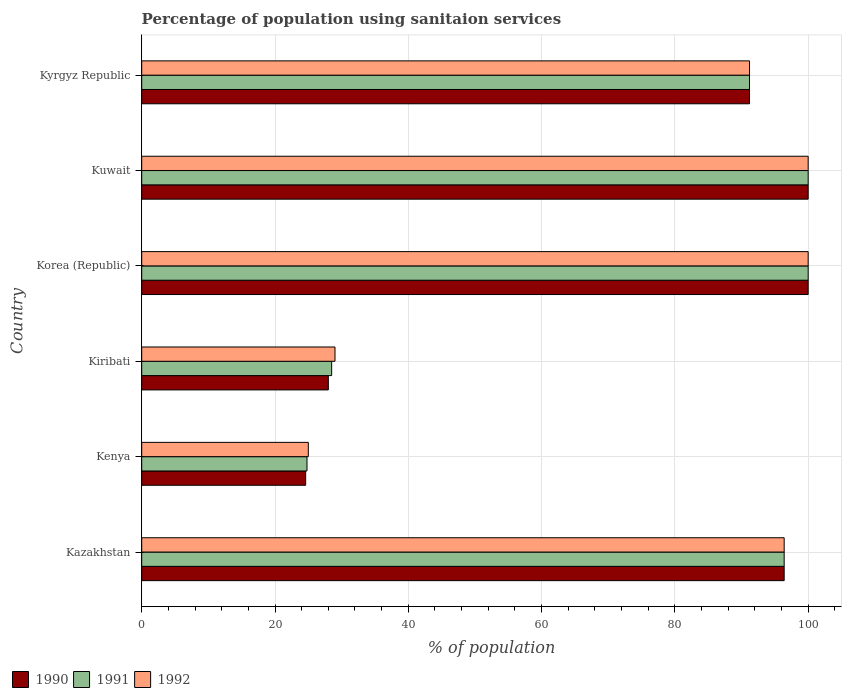How many different coloured bars are there?
Offer a very short reply. 3. How many bars are there on the 2nd tick from the top?
Your answer should be compact. 3. How many bars are there on the 6th tick from the bottom?
Keep it short and to the point. 3. What is the label of the 3rd group of bars from the top?
Offer a terse response. Korea (Republic). What is the percentage of population using sanitaion services in 1990 in Kyrgyz Republic?
Your answer should be very brief. 91.2. Across all countries, what is the maximum percentage of population using sanitaion services in 1990?
Your answer should be very brief. 100. Across all countries, what is the minimum percentage of population using sanitaion services in 1991?
Your answer should be compact. 24.8. In which country was the percentage of population using sanitaion services in 1992 maximum?
Your answer should be compact. Korea (Republic). In which country was the percentage of population using sanitaion services in 1992 minimum?
Your response must be concise. Kenya. What is the total percentage of population using sanitaion services in 1991 in the graph?
Make the answer very short. 440.9. What is the difference between the percentage of population using sanitaion services in 1990 in Kazakhstan and that in Kyrgyz Republic?
Your response must be concise. 5.2. What is the difference between the percentage of population using sanitaion services in 1992 in Kenya and the percentage of population using sanitaion services in 1990 in Kyrgyz Republic?
Make the answer very short. -66.2. What is the average percentage of population using sanitaion services in 1990 per country?
Provide a short and direct response. 73.37. What is the difference between the percentage of population using sanitaion services in 1992 and percentage of population using sanitaion services in 1990 in Kazakhstan?
Ensure brevity in your answer.  0. What is the ratio of the percentage of population using sanitaion services in 1990 in Kiribati to that in Kuwait?
Provide a succinct answer. 0.28. Is the percentage of population using sanitaion services in 1990 in Kuwait less than that in Kyrgyz Republic?
Make the answer very short. No. Is the difference between the percentage of population using sanitaion services in 1992 in Kiribati and Korea (Republic) greater than the difference between the percentage of population using sanitaion services in 1990 in Kiribati and Korea (Republic)?
Ensure brevity in your answer.  Yes. What is the difference between the highest and the second highest percentage of population using sanitaion services in 1991?
Your answer should be compact. 0. What is the difference between the highest and the lowest percentage of population using sanitaion services in 1992?
Offer a very short reply. 75. In how many countries, is the percentage of population using sanitaion services in 1990 greater than the average percentage of population using sanitaion services in 1990 taken over all countries?
Make the answer very short. 4. Is the sum of the percentage of population using sanitaion services in 1990 in Kiribati and Kyrgyz Republic greater than the maximum percentage of population using sanitaion services in 1992 across all countries?
Provide a succinct answer. Yes. What does the 3rd bar from the top in Kazakhstan represents?
Provide a short and direct response. 1990. What does the 1st bar from the bottom in Kiribati represents?
Your answer should be very brief. 1990. Is it the case that in every country, the sum of the percentage of population using sanitaion services in 1990 and percentage of population using sanitaion services in 1991 is greater than the percentage of population using sanitaion services in 1992?
Provide a short and direct response. Yes. How many bars are there?
Keep it short and to the point. 18. Are all the bars in the graph horizontal?
Ensure brevity in your answer.  Yes. How many countries are there in the graph?
Ensure brevity in your answer.  6. What is the difference between two consecutive major ticks on the X-axis?
Your answer should be very brief. 20. Are the values on the major ticks of X-axis written in scientific E-notation?
Ensure brevity in your answer.  No. How are the legend labels stacked?
Ensure brevity in your answer.  Horizontal. What is the title of the graph?
Offer a very short reply. Percentage of population using sanitaion services. Does "2003" appear as one of the legend labels in the graph?
Provide a succinct answer. No. What is the label or title of the X-axis?
Keep it short and to the point. % of population. What is the label or title of the Y-axis?
Offer a very short reply. Country. What is the % of population in 1990 in Kazakhstan?
Offer a terse response. 96.4. What is the % of population of 1991 in Kazakhstan?
Your answer should be very brief. 96.4. What is the % of population of 1992 in Kazakhstan?
Give a very brief answer. 96.4. What is the % of population of 1990 in Kenya?
Make the answer very short. 24.6. What is the % of population in 1991 in Kenya?
Give a very brief answer. 24.8. What is the % of population in 1991 in Korea (Republic)?
Make the answer very short. 100. What is the % of population in 1992 in Korea (Republic)?
Offer a very short reply. 100. What is the % of population of 1990 in Kyrgyz Republic?
Your response must be concise. 91.2. What is the % of population of 1991 in Kyrgyz Republic?
Ensure brevity in your answer.  91.2. What is the % of population in 1992 in Kyrgyz Republic?
Your answer should be compact. 91.2. Across all countries, what is the maximum % of population of 1990?
Offer a very short reply. 100. Across all countries, what is the maximum % of population of 1991?
Your answer should be compact. 100. Across all countries, what is the maximum % of population in 1992?
Your response must be concise. 100. Across all countries, what is the minimum % of population of 1990?
Your answer should be compact. 24.6. Across all countries, what is the minimum % of population in 1991?
Offer a very short reply. 24.8. What is the total % of population of 1990 in the graph?
Make the answer very short. 440.2. What is the total % of population of 1991 in the graph?
Provide a short and direct response. 440.9. What is the total % of population in 1992 in the graph?
Ensure brevity in your answer.  441.6. What is the difference between the % of population in 1990 in Kazakhstan and that in Kenya?
Your answer should be compact. 71.8. What is the difference between the % of population of 1991 in Kazakhstan and that in Kenya?
Give a very brief answer. 71.6. What is the difference between the % of population of 1992 in Kazakhstan and that in Kenya?
Your answer should be very brief. 71.4. What is the difference between the % of population in 1990 in Kazakhstan and that in Kiribati?
Give a very brief answer. 68.4. What is the difference between the % of population in 1991 in Kazakhstan and that in Kiribati?
Your answer should be compact. 67.9. What is the difference between the % of population of 1992 in Kazakhstan and that in Kiribati?
Provide a succinct answer. 67.4. What is the difference between the % of population in 1991 in Kazakhstan and that in Korea (Republic)?
Provide a short and direct response. -3.6. What is the difference between the % of population in 1990 in Kazakhstan and that in Kuwait?
Your response must be concise. -3.6. What is the difference between the % of population in 1992 in Kazakhstan and that in Kuwait?
Provide a succinct answer. -3.6. What is the difference between the % of population of 1990 in Kazakhstan and that in Kyrgyz Republic?
Provide a succinct answer. 5.2. What is the difference between the % of population in 1991 in Kazakhstan and that in Kyrgyz Republic?
Your response must be concise. 5.2. What is the difference between the % of population of 1992 in Kazakhstan and that in Kyrgyz Republic?
Your response must be concise. 5.2. What is the difference between the % of population of 1990 in Kenya and that in Kiribati?
Provide a succinct answer. -3.4. What is the difference between the % of population of 1992 in Kenya and that in Kiribati?
Your response must be concise. -4. What is the difference between the % of population in 1990 in Kenya and that in Korea (Republic)?
Offer a very short reply. -75.4. What is the difference between the % of population of 1991 in Kenya and that in Korea (Republic)?
Provide a short and direct response. -75.2. What is the difference between the % of population in 1992 in Kenya and that in Korea (Republic)?
Keep it short and to the point. -75. What is the difference between the % of population in 1990 in Kenya and that in Kuwait?
Offer a very short reply. -75.4. What is the difference between the % of population in 1991 in Kenya and that in Kuwait?
Your answer should be very brief. -75.2. What is the difference between the % of population in 1992 in Kenya and that in Kuwait?
Provide a succinct answer. -75. What is the difference between the % of population of 1990 in Kenya and that in Kyrgyz Republic?
Your response must be concise. -66.6. What is the difference between the % of population of 1991 in Kenya and that in Kyrgyz Republic?
Ensure brevity in your answer.  -66.4. What is the difference between the % of population in 1992 in Kenya and that in Kyrgyz Republic?
Your answer should be compact. -66.2. What is the difference between the % of population in 1990 in Kiribati and that in Korea (Republic)?
Ensure brevity in your answer.  -72. What is the difference between the % of population in 1991 in Kiribati and that in Korea (Republic)?
Make the answer very short. -71.5. What is the difference between the % of population in 1992 in Kiribati and that in Korea (Republic)?
Your answer should be very brief. -71. What is the difference between the % of population of 1990 in Kiribati and that in Kuwait?
Offer a very short reply. -72. What is the difference between the % of population of 1991 in Kiribati and that in Kuwait?
Provide a succinct answer. -71.5. What is the difference between the % of population of 1992 in Kiribati and that in Kuwait?
Provide a succinct answer. -71. What is the difference between the % of population in 1990 in Kiribati and that in Kyrgyz Republic?
Keep it short and to the point. -63.2. What is the difference between the % of population in 1991 in Kiribati and that in Kyrgyz Republic?
Offer a very short reply. -62.7. What is the difference between the % of population in 1992 in Kiribati and that in Kyrgyz Republic?
Make the answer very short. -62.2. What is the difference between the % of population in 1990 in Korea (Republic) and that in Kuwait?
Your answer should be compact. 0. What is the difference between the % of population in 1991 in Korea (Republic) and that in Kuwait?
Provide a succinct answer. 0. What is the difference between the % of population in 1992 in Korea (Republic) and that in Kuwait?
Your response must be concise. 0. What is the difference between the % of population of 1990 in Korea (Republic) and that in Kyrgyz Republic?
Your answer should be compact. 8.8. What is the difference between the % of population of 1991 in Korea (Republic) and that in Kyrgyz Republic?
Provide a short and direct response. 8.8. What is the difference between the % of population of 1990 in Kuwait and that in Kyrgyz Republic?
Provide a short and direct response. 8.8. What is the difference between the % of population of 1991 in Kuwait and that in Kyrgyz Republic?
Offer a very short reply. 8.8. What is the difference between the % of population in 1990 in Kazakhstan and the % of population in 1991 in Kenya?
Keep it short and to the point. 71.6. What is the difference between the % of population in 1990 in Kazakhstan and the % of population in 1992 in Kenya?
Ensure brevity in your answer.  71.4. What is the difference between the % of population in 1991 in Kazakhstan and the % of population in 1992 in Kenya?
Keep it short and to the point. 71.4. What is the difference between the % of population in 1990 in Kazakhstan and the % of population in 1991 in Kiribati?
Ensure brevity in your answer.  67.9. What is the difference between the % of population of 1990 in Kazakhstan and the % of population of 1992 in Kiribati?
Offer a terse response. 67.4. What is the difference between the % of population in 1991 in Kazakhstan and the % of population in 1992 in Kiribati?
Make the answer very short. 67.4. What is the difference between the % of population in 1990 in Kazakhstan and the % of population in 1991 in Korea (Republic)?
Make the answer very short. -3.6. What is the difference between the % of population in 1990 in Kazakhstan and the % of population in 1992 in Korea (Republic)?
Provide a short and direct response. -3.6. What is the difference between the % of population of 1991 in Kazakhstan and the % of population of 1992 in Korea (Republic)?
Your response must be concise. -3.6. What is the difference between the % of population in 1990 in Kazakhstan and the % of population in 1991 in Kuwait?
Provide a short and direct response. -3.6. What is the difference between the % of population in 1990 in Kazakhstan and the % of population in 1992 in Kuwait?
Ensure brevity in your answer.  -3.6. What is the difference between the % of population in 1990 in Kazakhstan and the % of population in 1992 in Kyrgyz Republic?
Make the answer very short. 5.2. What is the difference between the % of population in 1991 in Kazakhstan and the % of population in 1992 in Kyrgyz Republic?
Make the answer very short. 5.2. What is the difference between the % of population of 1990 in Kenya and the % of population of 1992 in Kiribati?
Offer a terse response. -4.4. What is the difference between the % of population of 1991 in Kenya and the % of population of 1992 in Kiribati?
Keep it short and to the point. -4.2. What is the difference between the % of population in 1990 in Kenya and the % of population in 1991 in Korea (Republic)?
Your answer should be very brief. -75.4. What is the difference between the % of population of 1990 in Kenya and the % of population of 1992 in Korea (Republic)?
Your answer should be compact. -75.4. What is the difference between the % of population of 1991 in Kenya and the % of population of 1992 in Korea (Republic)?
Keep it short and to the point. -75.2. What is the difference between the % of population in 1990 in Kenya and the % of population in 1991 in Kuwait?
Give a very brief answer. -75.4. What is the difference between the % of population in 1990 in Kenya and the % of population in 1992 in Kuwait?
Give a very brief answer. -75.4. What is the difference between the % of population in 1991 in Kenya and the % of population in 1992 in Kuwait?
Give a very brief answer. -75.2. What is the difference between the % of population in 1990 in Kenya and the % of population in 1991 in Kyrgyz Republic?
Offer a very short reply. -66.6. What is the difference between the % of population of 1990 in Kenya and the % of population of 1992 in Kyrgyz Republic?
Provide a succinct answer. -66.6. What is the difference between the % of population of 1991 in Kenya and the % of population of 1992 in Kyrgyz Republic?
Make the answer very short. -66.4. What is the difference between the % of population in 1990 in Kiribati and the % of population in 1991 in Korea (Republic)?
Provide a short and direct response. -72. What is the difference between the % of population in 1990 in Kiribati and the % of population in 1992 in Korea (Republic)?
Give a very brief answer. -72. What is the difference between the % of population in 1991 in Kiribati and the % of population in 1992 in Korea (Republic)?
Ensure brevity in your answer.  -71.5. What is the difference between the % of population of 1990 in Kiribati and the % of population of 1991 in Kuwait?
Provide a succinct answer. -72. What is the difference between the % of population of 1990 in Kiribati and the % of population of 1992 in Kuwait?
Your answer should be compact. -72. What is the difference between the % of population of 1991 in Kiribati and the % of population of 1992 in Kuwait?
Offer a very short reply. -71.5. What is the difference between the % of population in 1990 in Kiribati and the % of population in 1991 in Kyrgyz Republic?
Offer a very short reply. -63.2. What is the difference between the % of population in 1990 in Kiribati and the % of population in 1992 in Kyrgyz Republic?
Your response must be concise. -63.2. What is the difference between the % of population of 1991 in Kiribati and the % of population of 1992 in Kyrgyz Republic?
Offer a terse response. -62.7. What is the difference between the % of population of 1990 in Korea (Republic) and the % of population of 1991 in Kuwait?
Your answer should be compact. 0. What is the difference between the % of population of 1990 in Korea (Republic) and the % of population of 1992 in Kuwait?
Your answer should be very brief. 0. What is the difference between the % of population in 1991 in Korea (Republic) and the % of population in 1992 in Kuwait?
Your response must be concise. 0. What is the difference between the % of population of 1990 in Korea (Republic) and the % of population of 1991 in Kyrgyz Republic?
Your answer should be very brief. 8.8. What is the difference between the % of population of 1990 in Korea (Republic) and the % of population of 1992 in Kyrgyz Republic?
Make the answer very short. 8.8. What is the difference between the % of population of 1991 in Korea (Republic) and the % of population of 1992 in Kyrgyz Republic?
Keep it short and to the point. 8.8. What is the difference between the % of population of 1990 in Kuwait and the % of population of 1991 in Kyrgyz Republic?
Give a very brief answer. 8.8. What is the difference between the % of population in 1990 in Kuwait and the % of population in 1992 in Kyrgyz Republic?
Your answer should be compact. 8.8. What is the difference between the % of population in 1991 in Kuwait and the % of population in 1992 in Kyrgyz Republic?
Ensure brevity in your answer.  8.8. What is the average % of population in 1990 per country?
Offer a very short reply. 73.37. What is the average % of population of 1991 per country?
Your answer should be very brief. 73.48. What is the average % of population in 1992 per country?
Your answer should be compact. 73.6. What is the difference between the % of population of 1990 and % of population of 1992 in Kenya?
Offer a terse response. -0.4. What is the difference between the % of population of 1991 and % of population of 1992 in Kenya?
Ensure brevity in your answer.  -0.2. What is the difference between the % of population of 1990 and % of population of 1992 in Kiribati?
Your response must be concise. -1. What is the difference between the % of population in 1991 and % of population in 1992 in Kiribati?
Your answer should be compact. -0.5. What is the difference between the % of population of 1990 and % of population of 1991 in Korea (Republic)?
Your response must be concise. 0. What is the difference between the % of population of 1990 and % of population of 1992 in Korea (Republic)?
Offer a terse response. 0. What is the difference between the % of population in 1991 and % of population in 1992 in Korea (Republic)?
Your answer should be very brief. 0. What is the difference between the % of population in 1990 and % of population in 1991 in Kuwait?
Give a very brief answer. 0. What is the difference between the % of population in 1991 and % of population in 1992 in Kuwait?
Give a very brief answer. 0. What is the difference between the % of population in 1990 and % of population in 1992 in Kyrgyz Republic?
Offer a terse response. 0. What is the ratio of the % of population of 1990 in Kazakhstan to that in Kenya?
Give a very brief answer. 3.92. What is the ratio of the % of population in 1991 in Kazakhstan to that in Kenya?
Make the answer very short. 3.89. What is the ratio of the % of population in 1992 in Kazakhstan to that in Kenya?
Make the answer very short. 3.86. What is the ratio of the % of population in 1990 in Kazakhstan to that in Kiribati?
Provide a succinct answer. 3.44. What is the ratio of the % of population of 1991 in Kazakhstan to that in Kiribati?
Provide a short and direct response. 3.38. What is the ratio of the % of population of 1992 in Kazakhstan to that in Kiribati?
Your answer should be compact. 3.32. What is the ratio of the % of population of 1991 in Kazakhstan to that in Korea (Republic)?
Keep it short and to the point. 0.96. What is the ratio of the % of population of 1990 in Kazakhstan to that in Kyrgyz Republic?
Offer a terse response. 1.06. What is the ratio of the % of population of 1991 in Kazakhstan to that in Kyrgyz Republic?
Offer a very short reply. 1.06. What is the ratio of the % of population of 1992 in Kazakhstan to that in Kyrgyz Republic?
Provide a short and direct response. 1.06. What is the ratio of the % of population in 1990 in Kenya to that in Kiribati?
Your answer should be compact. 0.88. What is the ratio of the % of population in 1991 in Kenya to that in Kiribati?
Offer a terse response. 0.87. What is the ratio of the % of population in 1992 in Kenya to that in Kiribati?
Offer a very short reply. 0.86. What is the ratio of the % of population in 1990 in Kenya to that in Korea (Republic)?
Make the answer very short. 0.25. What is the ratio of the % of population of 1991 in Kenya to that in Korea (Republic)?
Make the answer very short. 0.25. What is the ratio of the % of population in 1992 in Kenya to that in Korea (Republic)?
Provide a succinct answer. 0.25. What is the ratio of the % of population of 1990 in Kenya to that in Kuwait?
Offer a very short reply. 0.25. What is the ratio of the % of population in 1991 in Kenya to that in Kuwait?
Give a very brief answer. 0.25. What is the ratio of the % of population of 1992 in Kenya to that in Kuwait?
Your answer should be very brief. 0.25. What is the ratio of the % of population of 1990 in Kenya to that in Kyrgyz Republic?
Offer a very short reply. 0.27. What is the ratio of the % of population in 1991 in Kenya to that in Kyrgyz Republic?
Provide a short and direct response. 0.27. What is the ratio of the % of population in 1992 in Kenya to that in Kyrgyz Republic?
Offer a very short reply. 0.27. What is the ratio of the % of population in 1990 in Kiribati to that in Korea (Republic)?
Offer a very short reply. 0.28. What is the ratio of the % of population in 1991 in Kiribati to that in Korea (Republic)?
Make the answer very short. 0.28. What is the ratio of the % of population of 1992 in Kiribati to that in Korea (Republic)?
Offer a terse response. 0.29. What is the ratio of the % of population of 1990 in Kiribati to that in Kuwait?
Offer a terse response. 0.28. What is the ratio of the % of population of 1991 in Kiribati to that in Kuwait?
Ensure brevity in your answer.  0.28. What is the ratio of the % of population in 1992 in Kiribati to that in Kuwait?
Your response must be concise. 0.29. What is the ratio of the % of population in 1990 in Kiribati to that in Kyrgyz Republic?
Your answer should be compact. 0.31. What is the ratio of the % of population of 1991 in Kiribati to that in Kyrgyz Republic?
Offer a very short reply. 0.31. What is the ratio of the % of population of 1992 in Kiribati to that in Kyrgyz Republic?
Keep it short and to the point. 0.32. What is the ratio of the % of population in 1990 in Korea (Republic) to that in Kuwait?
Make the answer very short. 1. What is the ratio of the % of population of 1991 in Korea (Republic) to that in Kuwait?
Your answer should be very brief. 1. What is the ratio of the % of population of 1992 in Korea (Republic) to that in Kuwait?
Your answer should be compact. 1. What is the ratio of the % of population in 1990 in Korea (Republic) to that in Kyrgyz Republic?
Offer a very short reply. 1.1. What is the ratio of the % of population in 1991 in Korea (Republic) to that in Kyrgyz Republic?
Offer a terse response. 1.1. What is the ratio of the % of population of 1992 in Korea (Republic) to that in Kyrgyz Republic?
Give a very brief answer. 1.1. What is the ratio of the % of population in 1990 in Kuwait to that in Kyrgyz Republic?
Provide a short and direct response. 1.1. What is the ratio of the % of population of 1991 in Kuwait to that in Kyrgyz Republic?
Ensure brevity in your answer.  1.1. What is the ratio of the % of population of 1992 in Kuwait to that in Kyrgyz Republic?
Give a very brief answer. 1.1. What is the difference between the highest and the lowest % of population in 1990?
Your answer should be compact. 75.4. What is the difference between the highest and the lowest % of population in 1991?
Your answer should be compact. 75.2. What is the difference between the highest and the lowest % of population of 1992?
Make the answer very short. 75. 